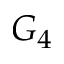Convert formula to latex. <formula><loc_0><loc_0><loc_500><loc_500>G _ { 4 }</formula> 